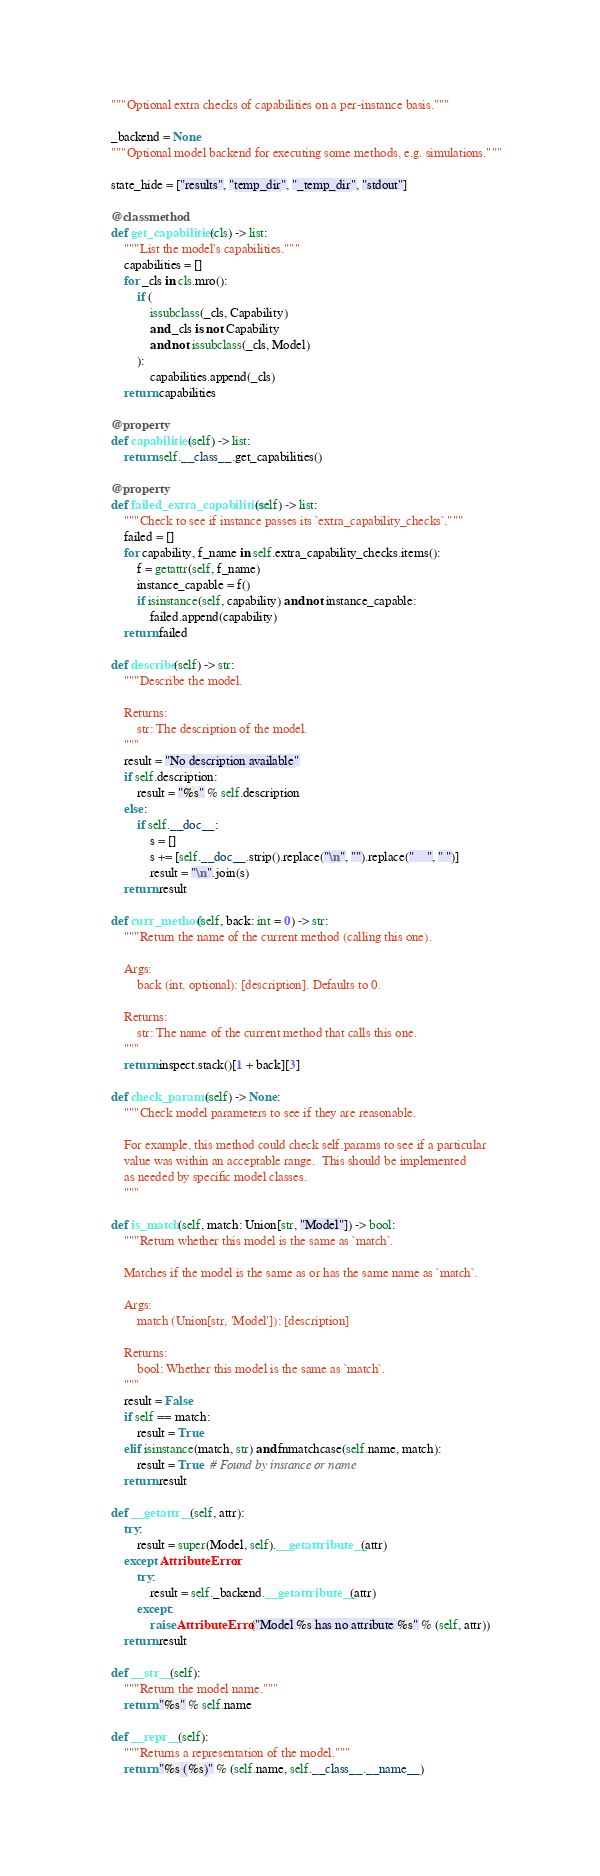<code> <loc_0><loc_0><loc_500><loc_500><_Python_>    """Optional extra checks of capabilities on a per-instance basis."""

    _backend = None
    """Optional model backend for executing some methods, e.g. simulations."""

    state_hide = ["results", "temp_dir", "_temp_dir", "stdout"]

    @classmethod
    def get_capabilities(cls) -> list:
        """List the model's capabilities."""
        capabilities = []
        for _cls in cls.mro():
            if (
                issubclass(_cls, Capability)
                and _cls is not Capability
                and not issubclass(_cls, Model)
            ):
                capabilities.append(_cls)
        return capabilities

    @property
    def capabilities(self) -> list:
        return self.__class__.get_capabilities()

    @property
    def failed_extra_capabilities(self) -> list:
        """Check to see if instance passes its `extra_capability_checks`."""
        failed = []
        for capability, f_name in self.extra_capability_checks.items():
            f = getattr(self, f_name)
            instance_capable = f()
            if isinstance(self, capability) and not instance_capable:
                failed.append(capability)
        return failed

    def describe(self) -> str:
        """Describe the model.

        Returns:
            str: The description of the model.
        """
        result = "No description available"
        if self.description:
            result = "%s" % self.description
        else:
            if self.__doc__:
                s = []
                s += [self.__doc__.strip().replace("\n", "").replace("    ", " ")]
                result = "\n".join(s)
        return result

    def curr_method(self, back: int = 0) -> str:
        """Return the name of the current method (calling this one).

        Args:
            back (int, optional): [description]. Defaults to 0.

        Returns:
            str: The name of the current method that calls this one.
        """
        return inspect.stack()[1 + back][3]

    def check_params(self) -> None:
        """Check model parameters to see if they are reasonable.

        For example, this method could check self.params to see if a particular
        value was within an acceptable range.  This should be implemented
        as needed by specific model classes.
        """

    def is_match(self, match: Union[str, "Model"]) -> bool:
        """Return whether this model is the same as `match`.

        Matches if the model is the same as or has the same name as `match`.

        Args:
            match (Union[str, 'Model']): [description]

        Returns:
            bool: Whether this model is the same as `match`.
        """
        result = False
        if self == match:
            result = True
        elif isinstance(match, str) and fnmatchcase(self.name, match):
            result = True  # Found by instance or name
        return result

    def __getattr__(self, attr):
        try:
            result = super(Model, self).__getattribute__(attr)
        except AttributeError:
            try:
                result = self._backend.__getattribute__(attr)
            except:
                raise AttributeError("Model %s has no attribute %s" % (self, attr))
        return result

    def __str__(self):
        """Return the model name."""
        return "%s" % self.name

    def __repr__(self):
        """Returns a representation of the model."""
        return "%s (%s)" % (self.name, self.__class__.__name__)
</code> 